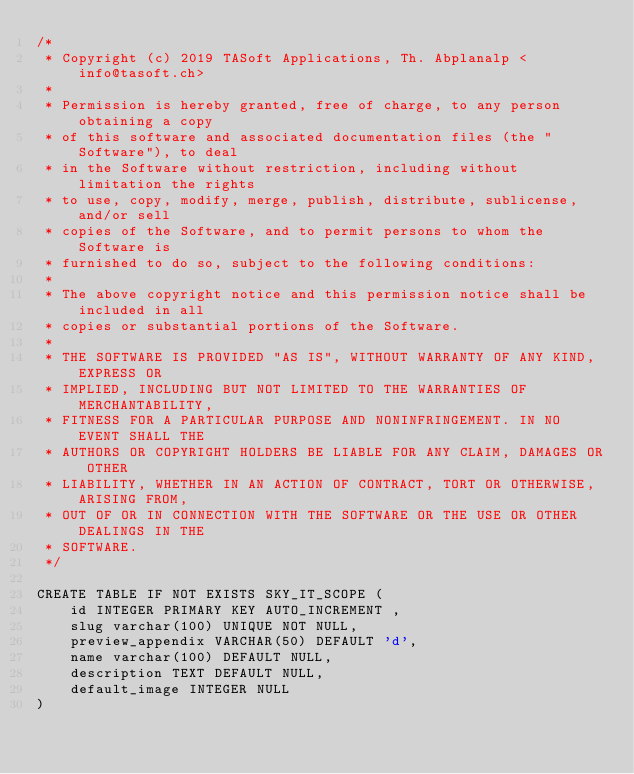Convert code to text. <code><loc_0><loc_0><loc_500><loc_500><_SQL_>/*
 * Copyright (c) 2019 TASoft Applications, Th. Abplanalp <info@tasoft.ch>
 *
 * Permission is hereby granted, free of charge, to any person obtaining a copy
 * of this software and associated documentation files (the "Software"), to deal
 * in the Software without restriction, including without limitation the rights
 * to use, copy, modify, merge, publish, distribute, sublicense, and/or sell
 * copies of the Software, and to permit persons to whom the Software is
 * furnished to do so, subject to the following conditions:
 *
 * The above copyright notice and this permission notice shall be included in all
 * copies or substantial portions of the Software.
 *
 * THE SOFTWARE IS PROVIDED "AS IS", WITHOUT WARRANTY OF ANY KIND, EXPRESS OR
 * IMPLIED, INCLUDING BUT NOT LIMITED TO THE WARRANTIES OF MERCHANTABILITY,
 * FITNESS FOR A PARTICULAR PURPOSE AND NONINFRINGEMENT. IN NO EVENT SHALL THE
 * AUTHORS OR COPYRIGHT HOLDERS BE LIABLE FOR ANY CLAIM, DAMAGES OR OTHER
 * LIABILITY, WHETHER IN AN ACTION OF CONTRACT, TORT OR OTHERWISE, ARISING FROM,
 * OUT OF OR IN CONNECTION WITH THE SOFTWARE OR THE USE OR OTHER DEALINGS IN THE
 * SOFTWARE.
 */

CREATE TABLE IF NOT EXISTS SKY_IT_SCOPE (
    id INTEGER PRIMARY KEY AUTO_INCREMENT ,
    slug varchar(100) UNIQUE NOT NULL,
    preview_appendix VARCHAR(50) DEFAULT 'd',
    name varchar(100) DEFAULT NULL,
    description TEXT DEFAULT NULL,
    default_image INTEGER NULL
)</code> 